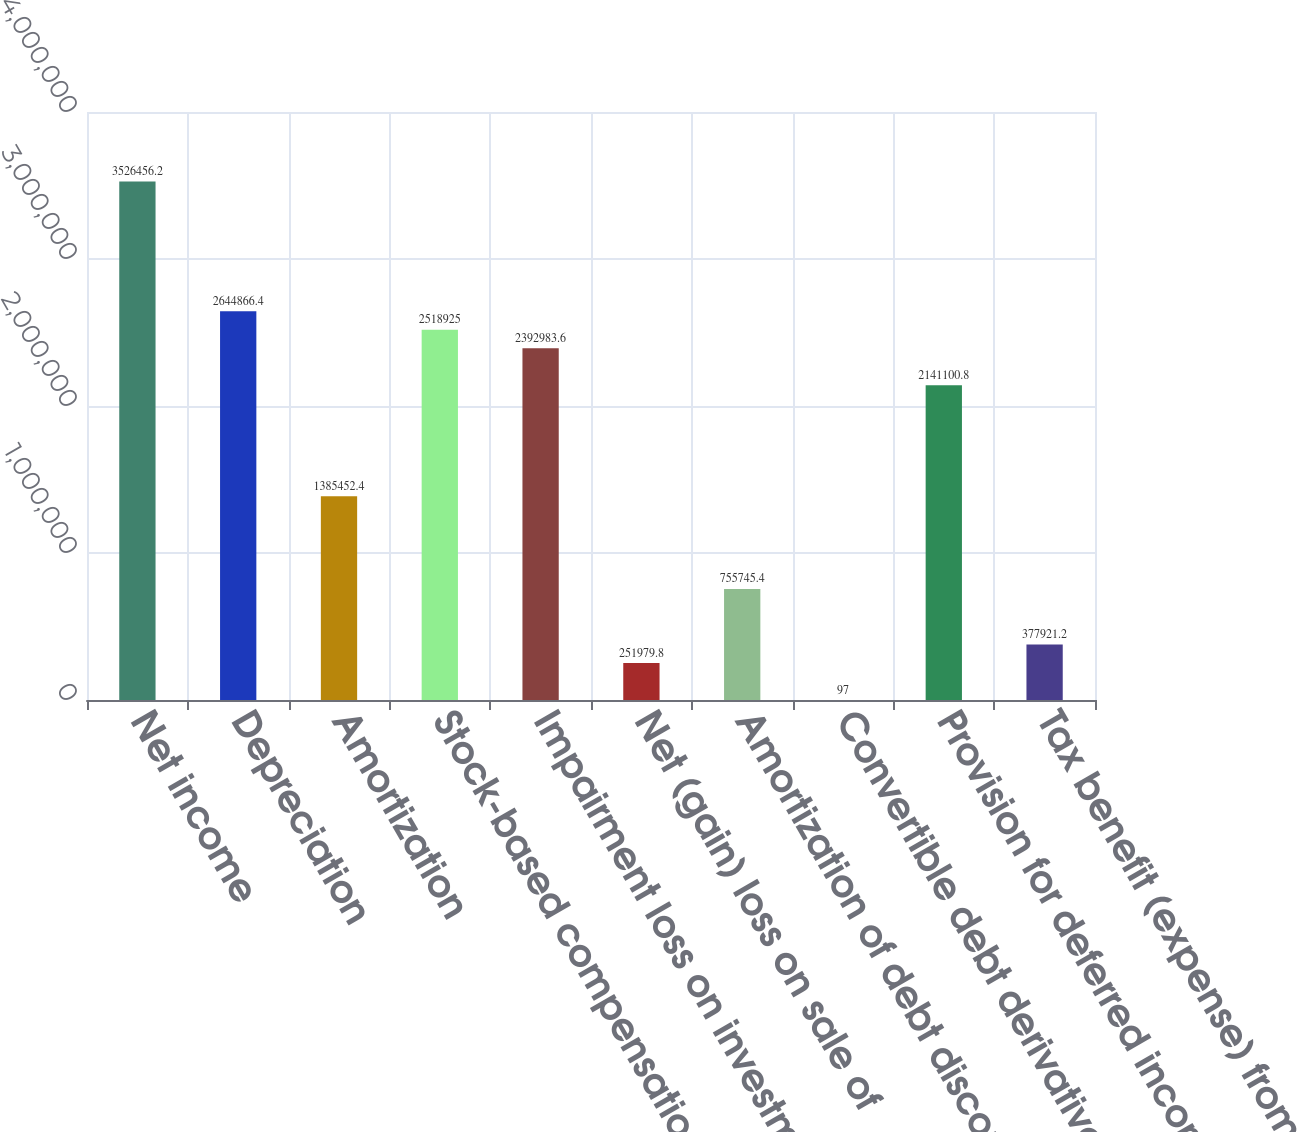Convert chart. <chart><loc_0><loc_0><loc_500><loc_500><bar_chart><fcel>Net income<fcel>Depreciation<fcel>Amortization<fcel>Stock-based compensation<fcel>Impairment loss on investments<fcel>Net (gain) loss on sale of<fcel>Amortization of debt discount<fcel>Convertible debt derivatives -<fcel>Provision for deferred income<fcel>Tax benefit (expense) from<nl><fcel>3.52646e+06<fcel>2.64487e+06<fcel>1.38545e+06<fcel>2.51892e+06<fcel>2.39298e+06<fcel>251980<fcel>755745<fcel>97<fcel>2.1411e+06<fcel>377921<nl></chart> 